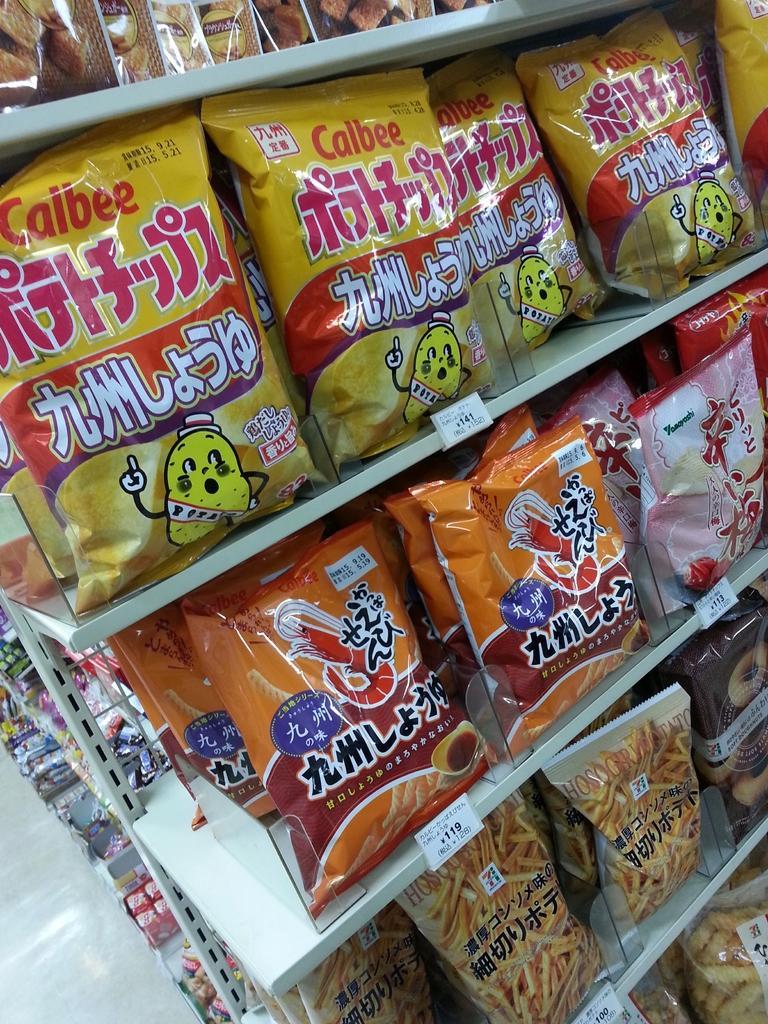In one or two sentences, can you explain what this image depicts? In the foreground of this image, there are few products in the shelf. In the background, there are few products and the floor. 